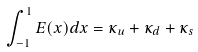<formula> <loc_0><loc_0><loc_500><loc_500>\int _ { - 1 } ^ { 1 } E ( x ) d x = \kappa _ { u } + \kappa _ { d } + \kappa _ { s }</formula> 